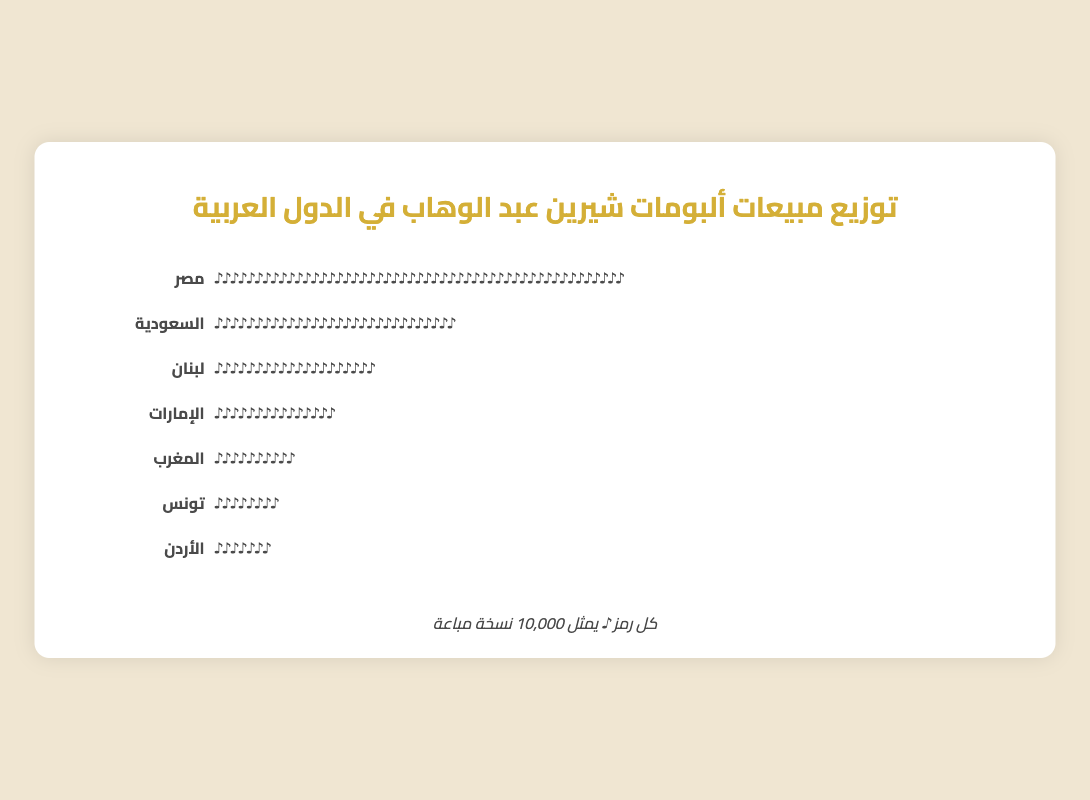Which country has the highest album sales for Sherine Abdelwahab? According to the figure, Egypt has the highest number of music notes, which represent the sales.
Answer: Egypt How many music notes represent the sales in Morocco? The figure shows 10 music notes for Morocco. Each note represents 10,000 copies.
Answer: 100,000 What is the total sales in United Arab Emirates and Jordan combined? UAE has 15 music notes and Jordan has 7 music notes. Together, this totals 22 music notes, which represents 220,000 copies.
Answer: 220,000 Which country has more album sales, Saudi Arabia or Lebanon, and by how much? Saudi Arabia has 30 music notes, while Lebanon has 20. The difference is 10 music notes, which represents 100,000 copies.
Answer: Saudi Arabia by 100,000 What percentage of the total sales does Egypt represent? Egypt has 50 music notes out of a total of 142 music notes (sum of all countries' notes). The percentage is (50/142) * 100.
Answer: 35.2% How do the album sales in Tunisia compare to Morocco? Tunisia has 8 music notes and Morocco has 10. Tunisia's sales are 2 music notes or 20,000 copies less than Morocco.
Answer: Less by 20,000 What is the sum of album sales in Lebanon, Saudi Arabia, and UAE? Lebanon has 20 music notes, Saudi Arabia has 30, and UAE has 15. The total is 65 music notes, which represents 650,000 copies.
Answer: 650,000 Which country has the smallest album sales for Sherine Abdelwahab? Jordan, with 7 music notes.
Answer: Jordan How do the sales in Egypt compare to those in the UAE and Tunisia combined? Egypt has 50 music notes, while UAE has 15 and Tunisia has 8. Combined, UAE and Tunisia have 23 music notes. Egypt has 27 more music notes, representing 270,000 more copies sold.
Answer: Egypt by 270,000 How many music notes are there in total in the entire Isotype Plot? Summing all music notes: 50 (Egypt) + 30 (Saudi Arabia) + 20 (Lebanon) + 15 (UAE) + 10 (Morocco) + 8 (Tunisia) + 7 (Jordan) = 140.
Answer: 140 